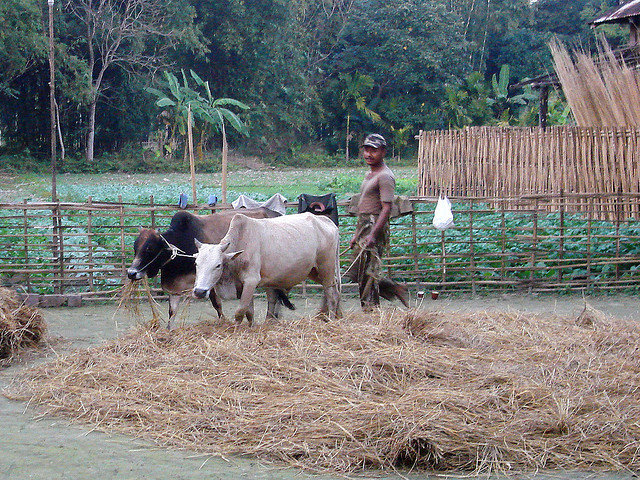What types of plants can we see in the background? The background is lush with various types of vegetation that suggest a rural, tropical setting. There are trees with large broad leaves, possibly banana or similar tropical species, along with what appears to be a dense undergrowth. Such diversity in plant life is indicative of a healthy ecosystem that supports a variety of wildlife and agriculture. 